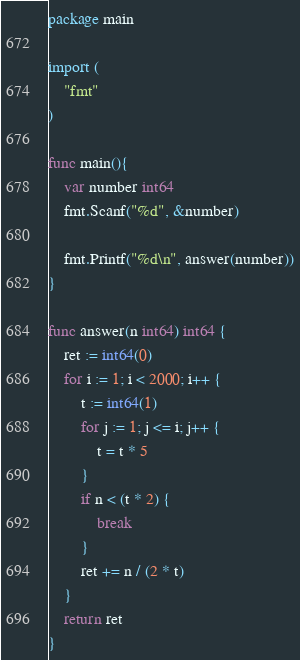Convert code to text. <code><loc_0><loc_0><loc_500><loc_500><_Go_>package main

import (
	"fmt"
)

func main(){
	var number int64
	fmt.Scanf("%d", &number)

	fmt.Printf("%d\n", answer(number))
}

func answer(n int64) int64 {
	ret := int64(0)
	for i := 1; i < 2000; i++ {
		t := int64(1)
		for j := 1; j <= i; j++ {
			t = t * 5
		}
		if n < (t * 2) {
			break
		}
		ret += n / (2 * t)
	}
	return ret
}</code> 